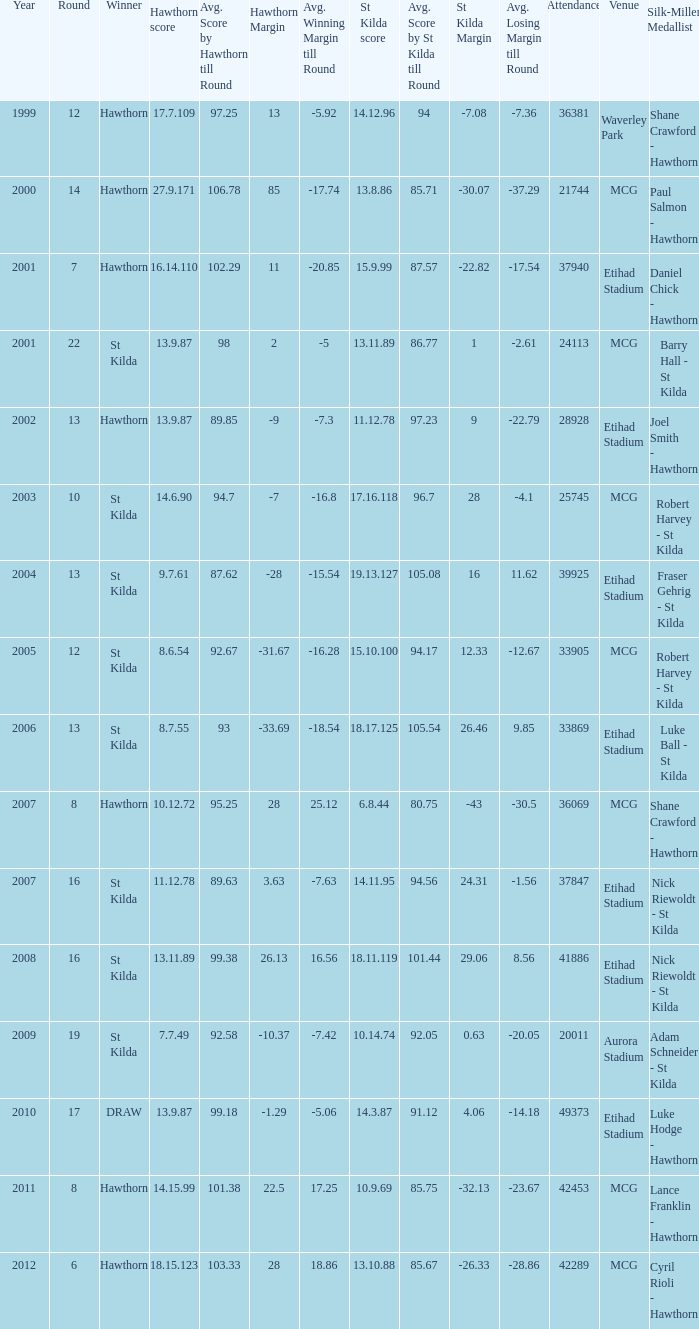What is the attendance when the st kilda score is 13.10.88? 42289.0. 